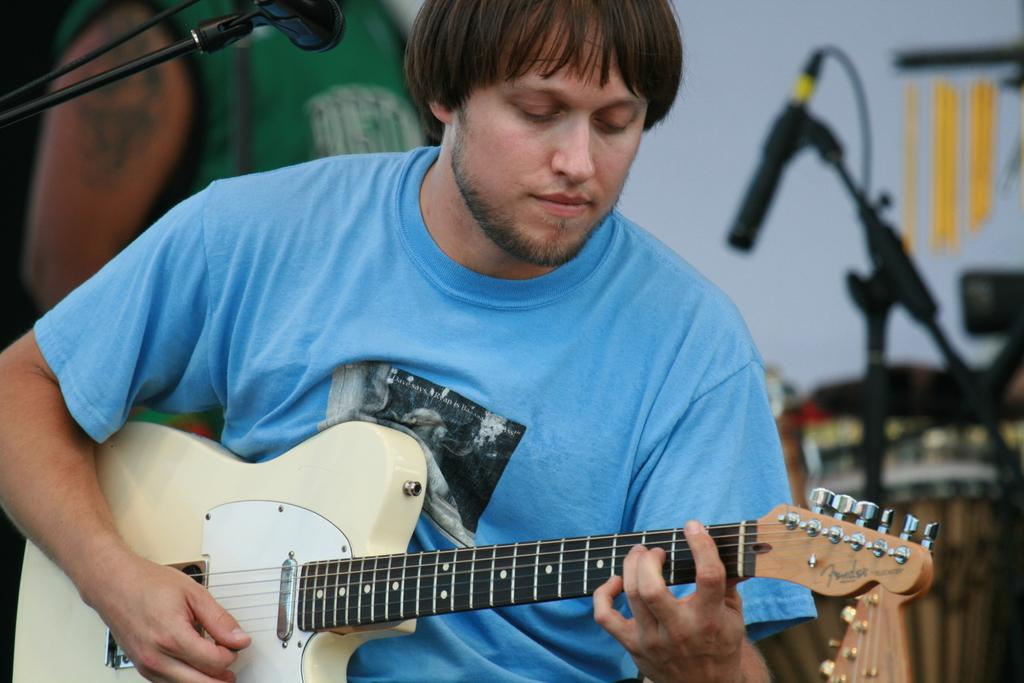What is the man in the image doing? The man is playing a guitar in the image. What is the man wearing? The man is wearing a blue t-shirt in the image. What objects related to music can be seen in the image? There is a microphone in the top left of the image and a microphone stand in the right side of the image. What type of food is being prepared in the cemetery in the image? There is no cemetery or food preparation present in the image; it features a man playing a guitar. What instrument is being used to whip the audience in the image? There is no whip or instrument used to whip the audience in the image; the man is playing a guitar. 